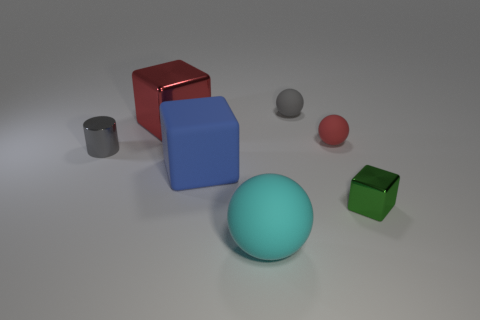The tiny rubber object in front of the gray thing behind the small metallic object behind the blue thing is what color?
Offer a terse response. Red. Does the matte block have the same size as the red ball?
Ensure brevity in your answer.  No. What number of blue things are the same size as the cyan matte thing?
Give a very brief answer. 1. The rubber thing that is the same color as the small cylinder is what shape?
Your answer should be very brief. Sphere. Do the red thing right of the gray matte object and the small thing left of the cyan rubber sphere have the same material?
Offer a very short reply. No. Is there any other thing that has the same shape as the big red object?
Keep it short and to the point. Yes. The big matte sphere has what color?
Provide a short and direct response. Cyan. What number of small gray rubber things have the same shape as the large shiny object?
Keep it short and to the point. 0. What color is the other rubber object that is the same size as the blue matte thing?
Give a very brief answer. Cyan. Is there a large metallic thing?
Provide a short and direct response. Yes. 